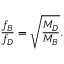<formula> <loc_0><loc_0><loc_500><loc_500>{ \frac { f _ { B } } { f _ { D } } } = \sqrt { \frac { M _ { D } } { M _ { B } } } .</formula> 